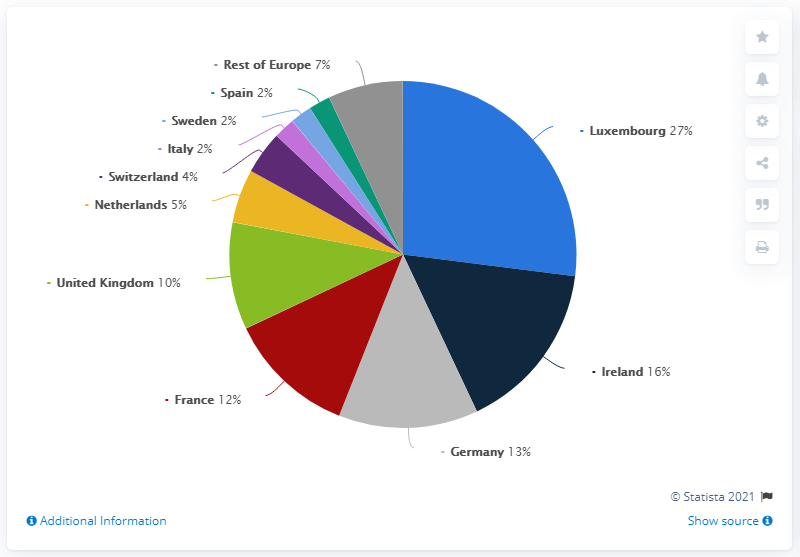Mention a couple of crucial points in this snapshot. The majority of European investment funds were domiciled in Luxembourg. In 2018, approximately 27% of the total market of European investment funds were domiciled in Luxembourg. The ratio of the red segment and the largest segment of the pie is 0.444444444... The market share of Spain in European investment funds in 2018 was 2%. 